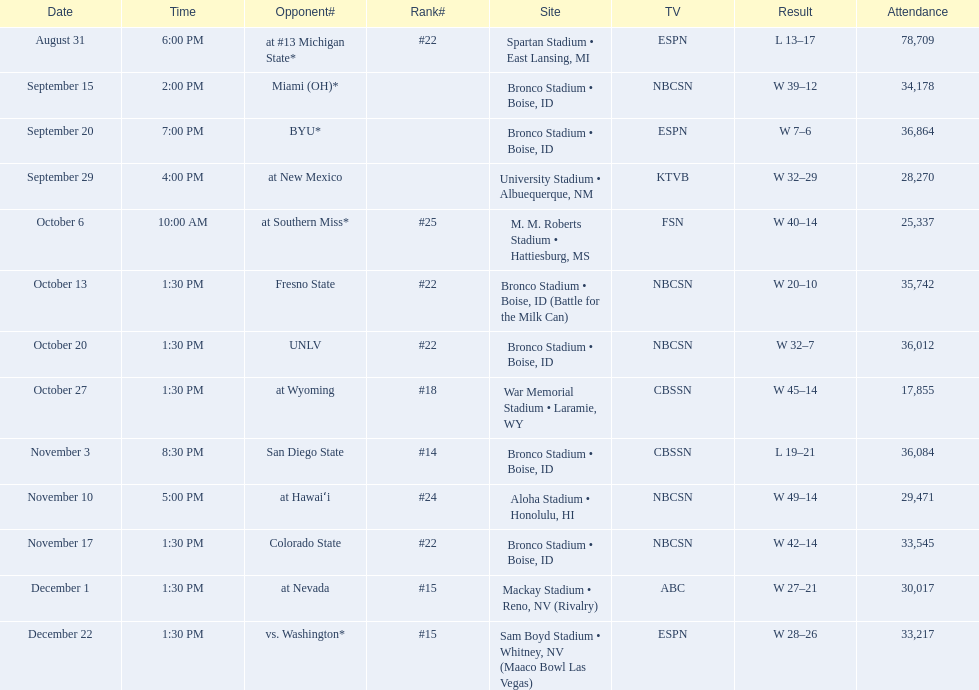Who are the adversaries of the 2012 boise state broncos football team? At #13 michigan state*, miami (oh)*, byu*, at new mexico, at southern miss*, fresno state, unlv, at wyoming, san diego state, at hawaiʻi, colorado state, at nevada, vs. washington*. Which is the top-rated among the teams? San Diego State. 